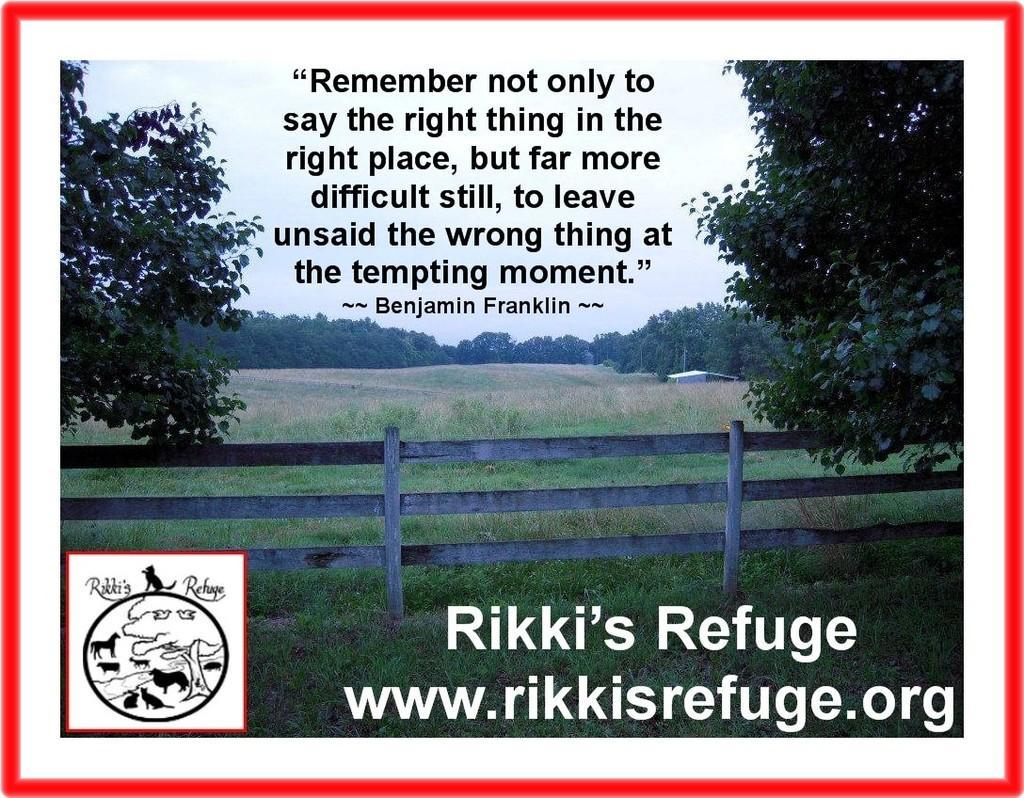Please provide a concise description of this image. In this picture there are trees and there is a house. In the foreground there is a wooden railing. At the top there is sky. At the bottom there is grass. At the top there is text. At the bottom there is text and there might be a logo. 